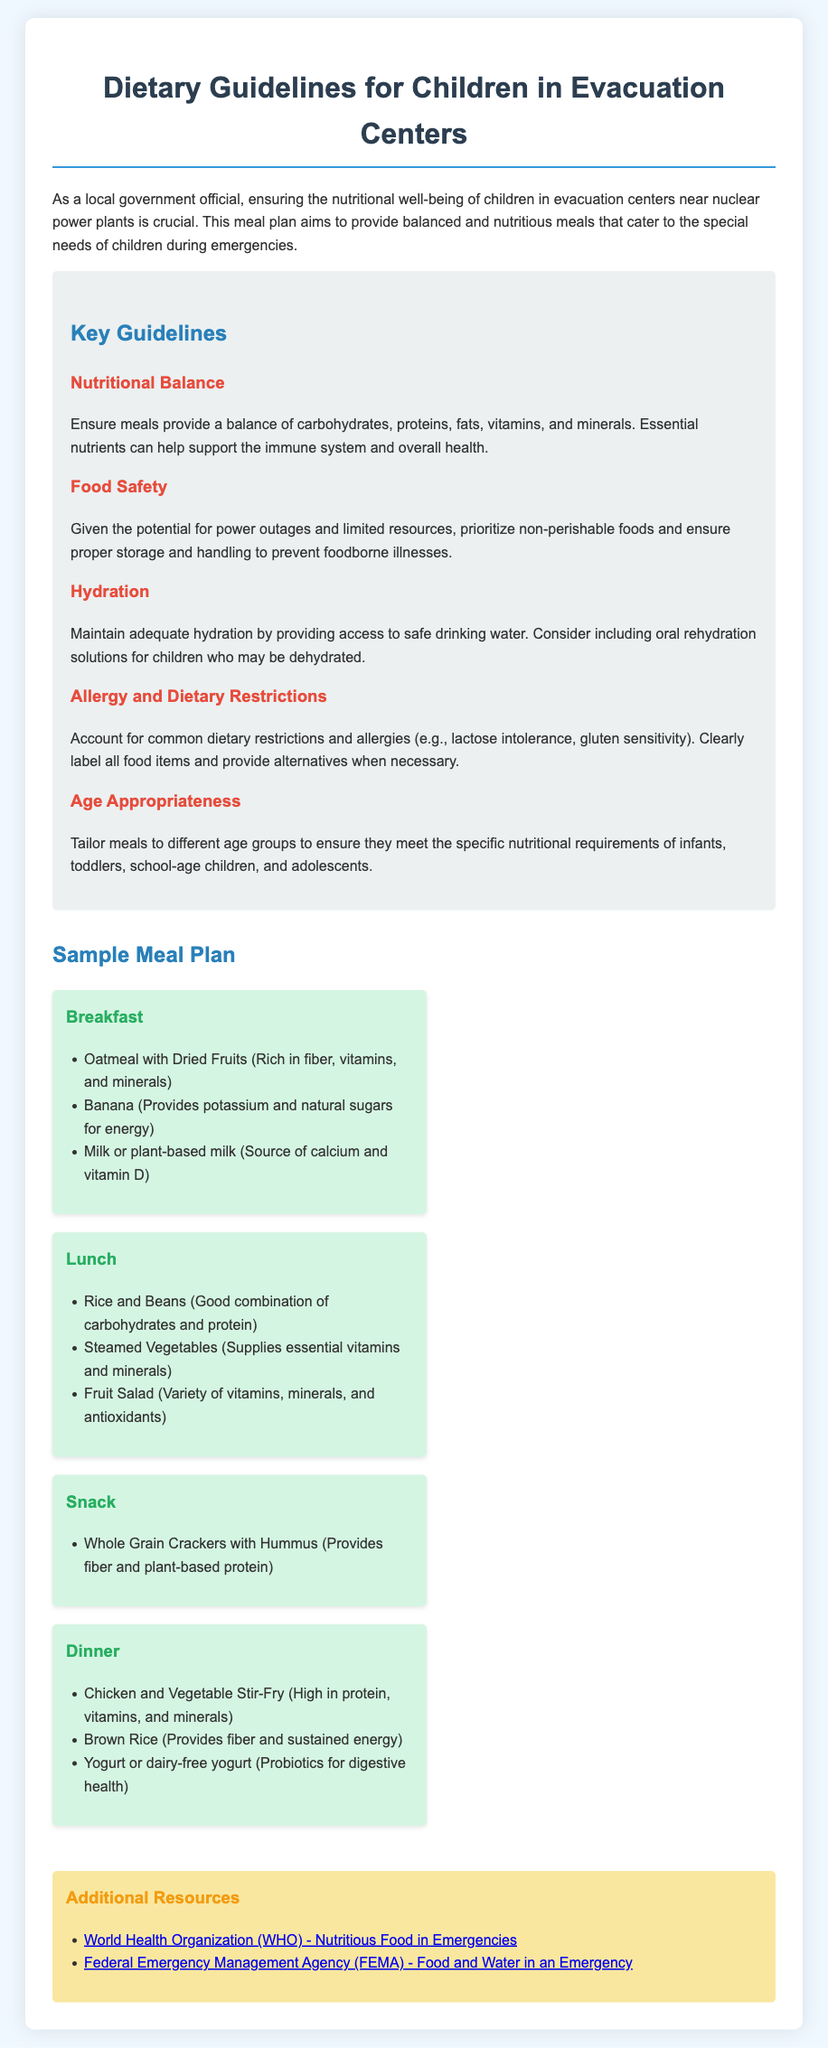What is the title of the document? The title is found in the header of the document, which is "Meal Plan for Children in Evacuation Centers."
Answer: Meal Plan for Children in Evacuation Centers What is one key guideline regarding food safety? The guideline mentions the need to prioritize non-perishable foods and ensure proper storage and handling to prevent foodborne illnesses.
Answer: Prioritize non-perishable foods How many meal categories are included in the sample meal plan? The document lists four meal categories: Breakfast, Lunch, Snack, and Dinner.
Answer: Four What is included in the breakfast meal? The breakfast meal includes oatmeal with dried fruits, a banana, and milk or plant-based milk.
Answer: Oatmeal with dried fruits, Banana, Milk or plant-based milk Which organization is mentioned as a resource for nutritious food in emergencies? The document provides a link to the World Health Organization for nutritious food guidance.
Answer: World Health Organization What is the purpose of this meal plan? The purpose is stated to ensure the nutritional well-being of children in evacuation centers during emergencies.
Answer: Nutritional well-being of children What type of vegetables are recommended for lunch? The lunch meal suggests steamed vegetables as part of the meal plan for children.
Answer: Steamed Vegetables What is a recommended drink for maintaining hydration? The document highlights the need to provide access to safe drinking water to maintain hydration.
Answer: Safe drinking water What kind of protein source is included in the dinner meal? The dinner meal incorporates chicken as a high-protein food option for children.
Answer: Chicken 